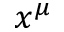Convert formula to latex. <formula><loc_0><loc_0><loc_500><loc_500>x ^ { \mu }</formula> 